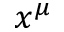Convert formula to latex. <formula><loc_0><loc_0><loc_500><loc_500>x ^ { \mu }</formula> 